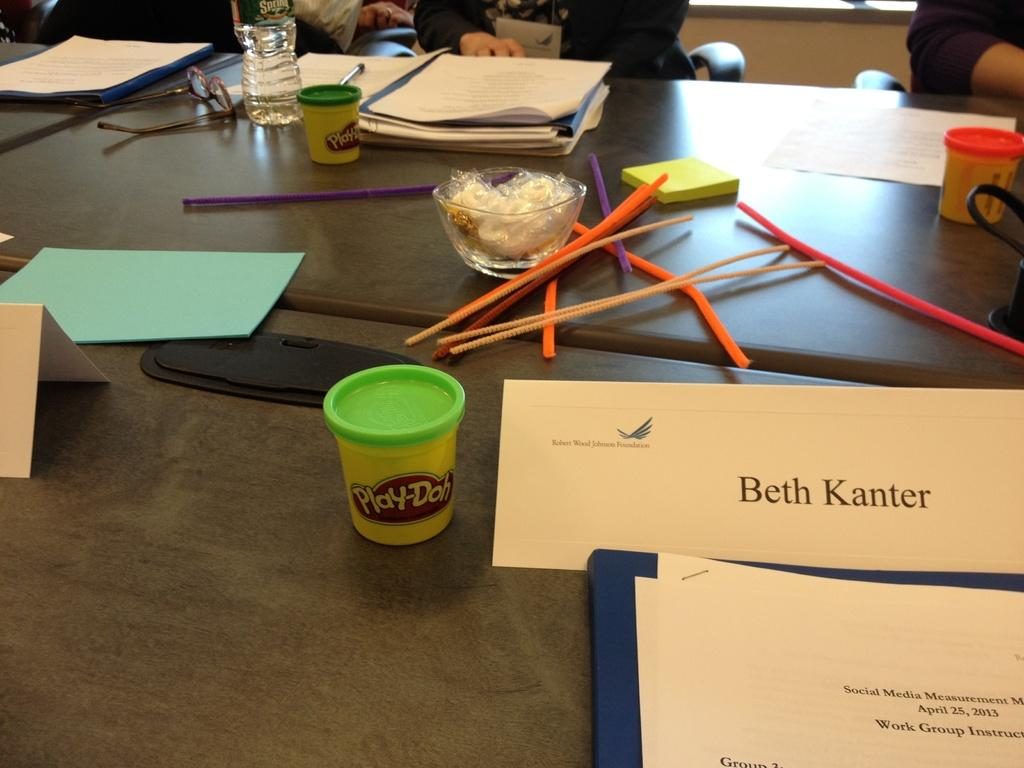What items can be seen on the table in the image? There are files, books, a water bottle, glasses, and sticks on the table. What might the persons sitting at the table be using the sticks for? The sticks could be used for writing or pointing, as they are on the table with other office-related items. What is the purpose of the water bottle on the table? The water bottle is likely for hydration, as it is a common item to have nearby while working or studying. How many persons are sitting at the table in the image? There are persons sitting on chairs at the table, but the exact number is not specified in the facts. What type of milk is being poured into the glasses on the table? There is no milk present in the image; only a water bottle is visible on the table. 